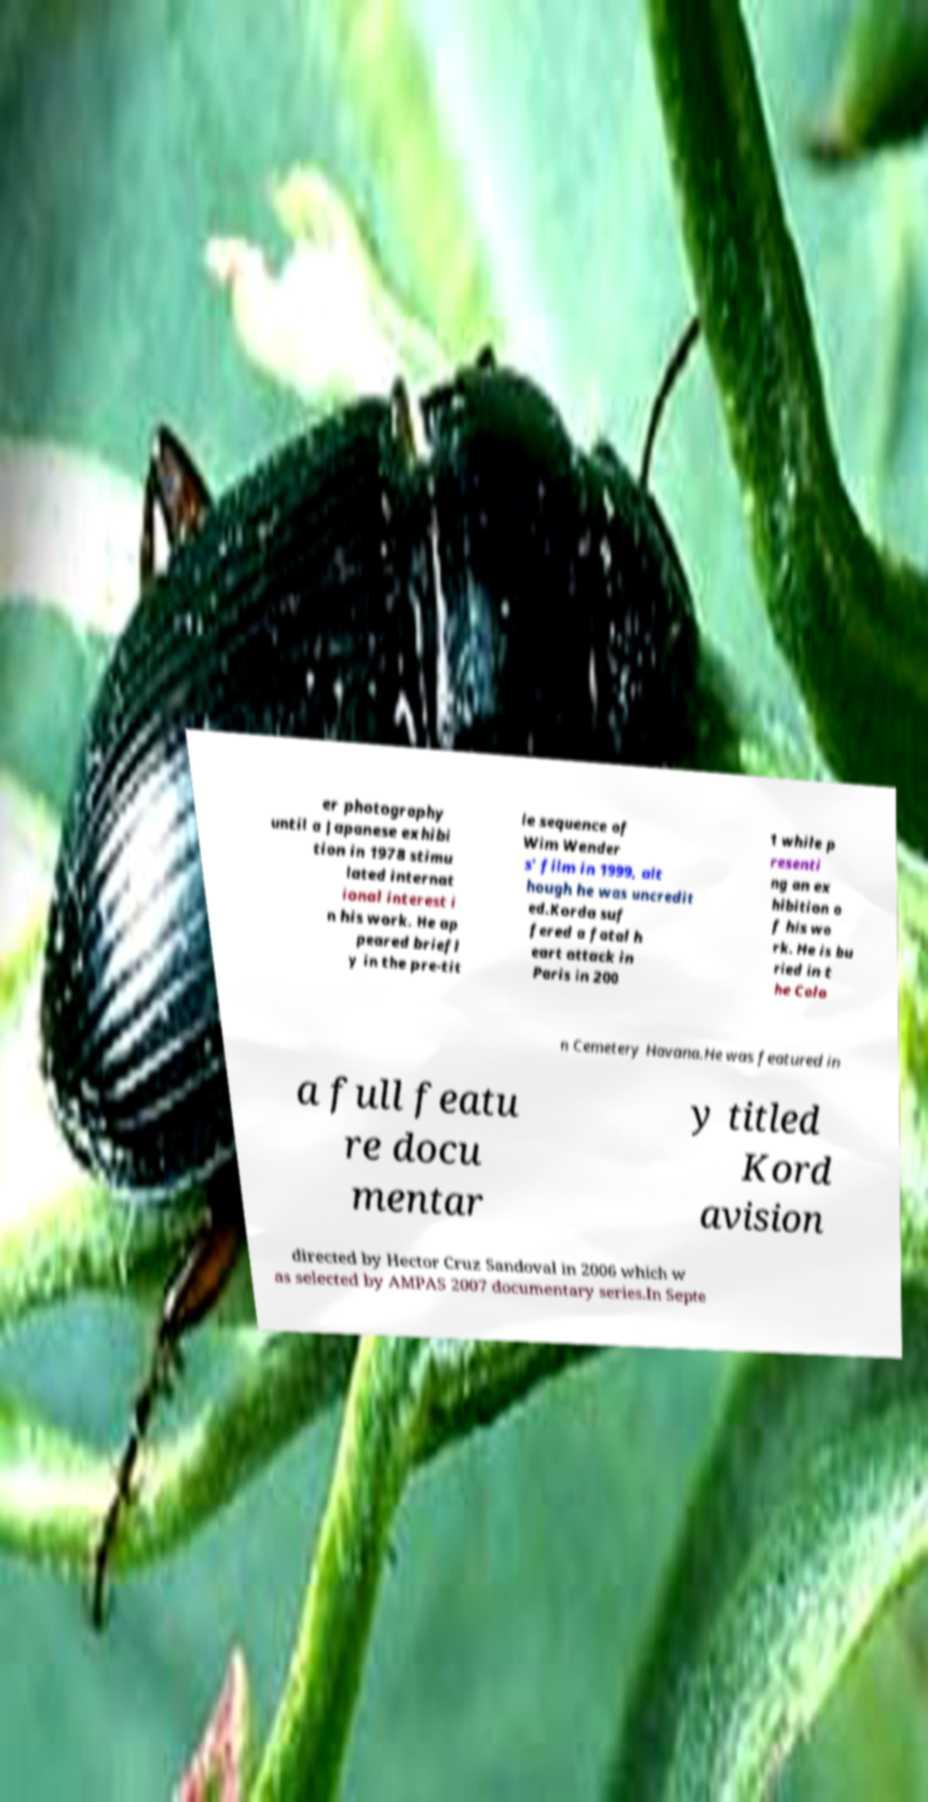Please identify and transcribe the text found in this image. er photography until a Japanese exhibi tion in 1978 stimu lated internat ional interest i n his work. He ap peared briefl y in the pre-tit le sequence of Wim Wender s' film in 1999, alt hough he was uncredit ed.Korda suf fered a fatal h eart attack in Paris in 200 1 while p resenti ng an ex hibition o f his wo rk. He is bu ried in t he Colo n Cemetery Havana.He was featured in a full featu re docu mentar y titled Kord avision directed by Hector Cruz Sandoval in 2006 which w as selected by AMPAS 2007 documentary series.In Septe 